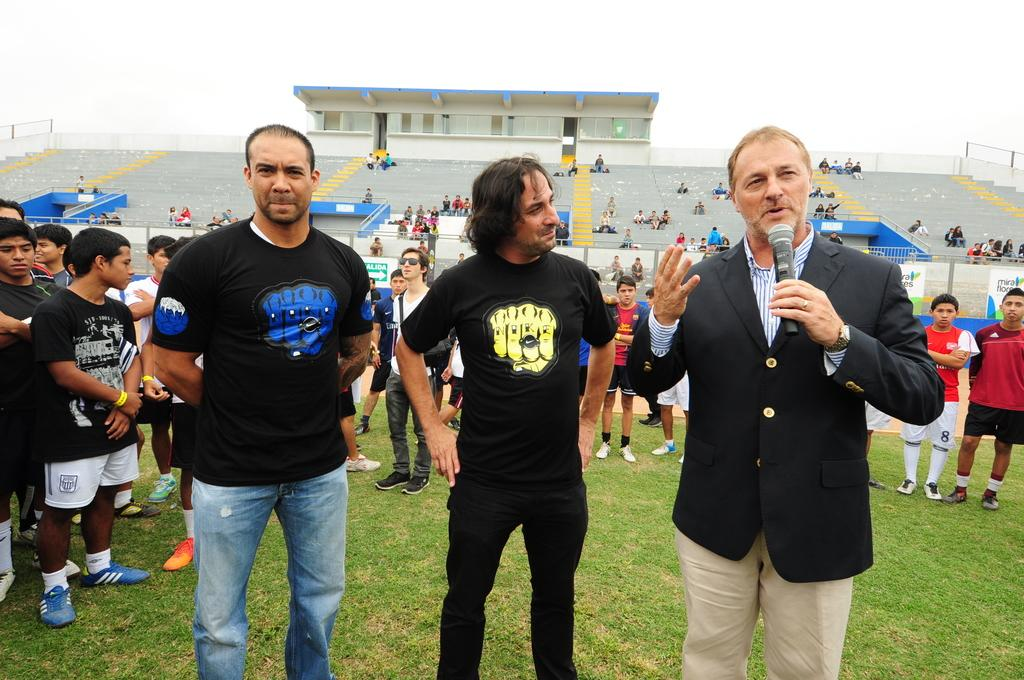How many people are in the image? There is a group of people in the image, but the exact number cannot be determined from the provided facts. What object is used for amplifying sound in the image? There is a mic in the image. What item might be used for carrying or storing items in the image? There is a bag in the image. What architectural feature is present in the image? There are stairs in the image. What type of structure is visible in the image? There is a house in the image. What material is used for the signs or notices in the image? There are boards in the image. What type of surface is visible in the image? There is ground visible in the image. What part of the natural environment is visible in the image? There is sky visible in the image. What type of barrier is present in the image? There is fencing in the image. What type of bean is being used to season the food in the image? There is no mention of food or seasoning in the image, so it is not possible to determine if any beans are present. How many hours are visible on the clock in the image? There is no clock present in the image, so it is not possible to determine the hour. 